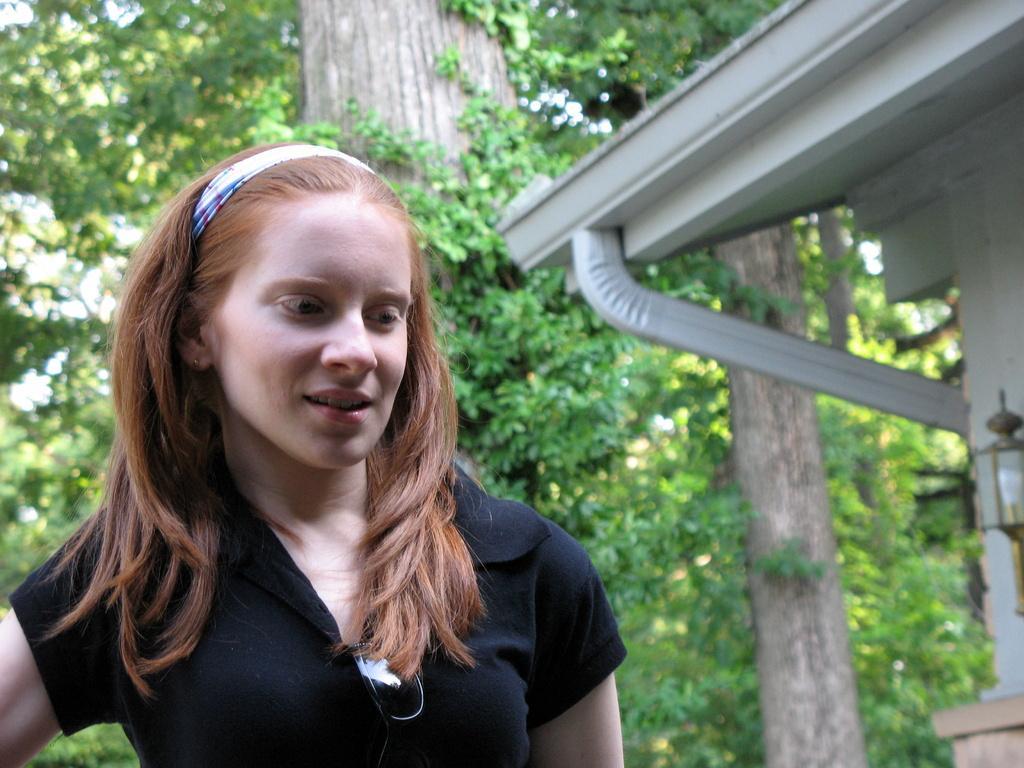Could you give a brief overview of what you see in this image? This picture is clicked outside. In the foreground we can see a woman wearing t-shirt and standing. On the right we can see the wall mounted lamp and an object which seems to be the building. In the background we can see the trees and some other objects. 